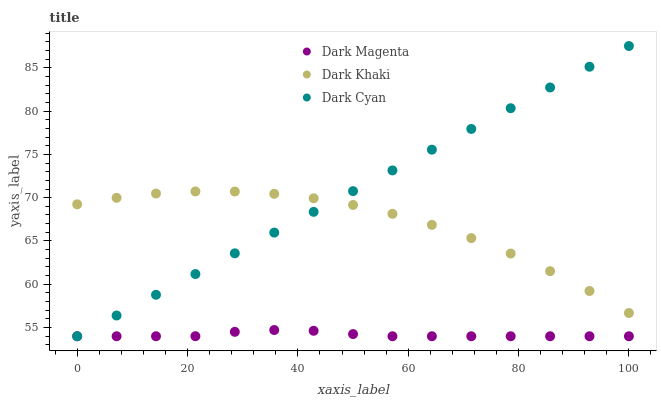Does Dark Magenta have the minimum area under the curve?
Answer yes or no. Yes. Does Dark Cyan have the maximum area under the curve?
Answer yes or no. Yes. Does Dark Cyan have the minimum area under the curve?
Answer yes or no. No. Does Dark Magenta have the maximum area under the curve?
Answer yes or no. No. Is Dark Cyan the smoothest?
Answer yes or no. Yes. Is Dark Khaki the roughest?
Answer yes or no. Yes. Is Dark Magenta the smoothest?
Answer yes or no. No. Is Dark Magenta the roughest?
Answer yes or no. No. Does Dark Cyan have the lowest value?
Answer yes or no. Yes. Does Dark Cyan have the highest value?
Answer yes or no. Yes. Does Dark Magenta have the highest value?
Answer yes or no. No. Is Dark Magenta less than Dark Khaki?
Answer yes or no. Yes. Is Dark Khaki greater than Dark Magenta?
Answer yes or no. Yes. Does Dark Cyan intersect Dark Magenta?
Answer yes or no. Yes. Is Dark Cyan less than Dark Magenta?
Answer yes or no. No. Is Dark Cyan greater than Dark Magenta?
Answer yes or no. No. Does Dark Magenta intersect Dark Khaki?
Answer yes or no. No. 